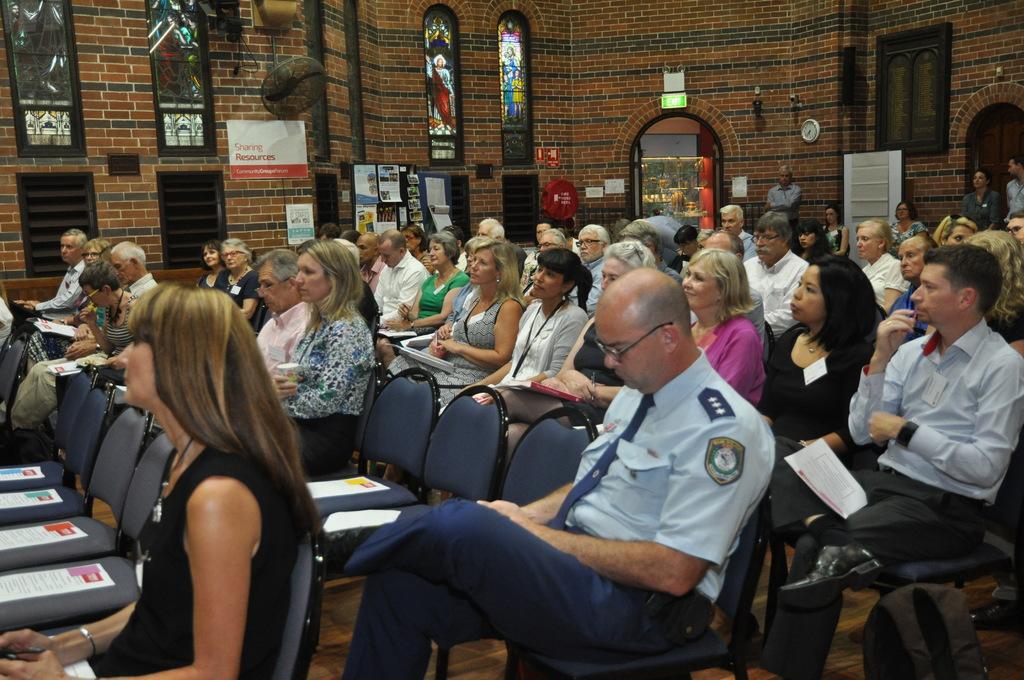How would you summarize this image in a sentence or two? In this picture there are group of people sitting on the chairs and there are papers on the chairs. At the back there are posters on the wall and there are three people standing. There is a door and there is text on the posters. There is a clock on the wall and there are windows. At the bottom there is a floor. 